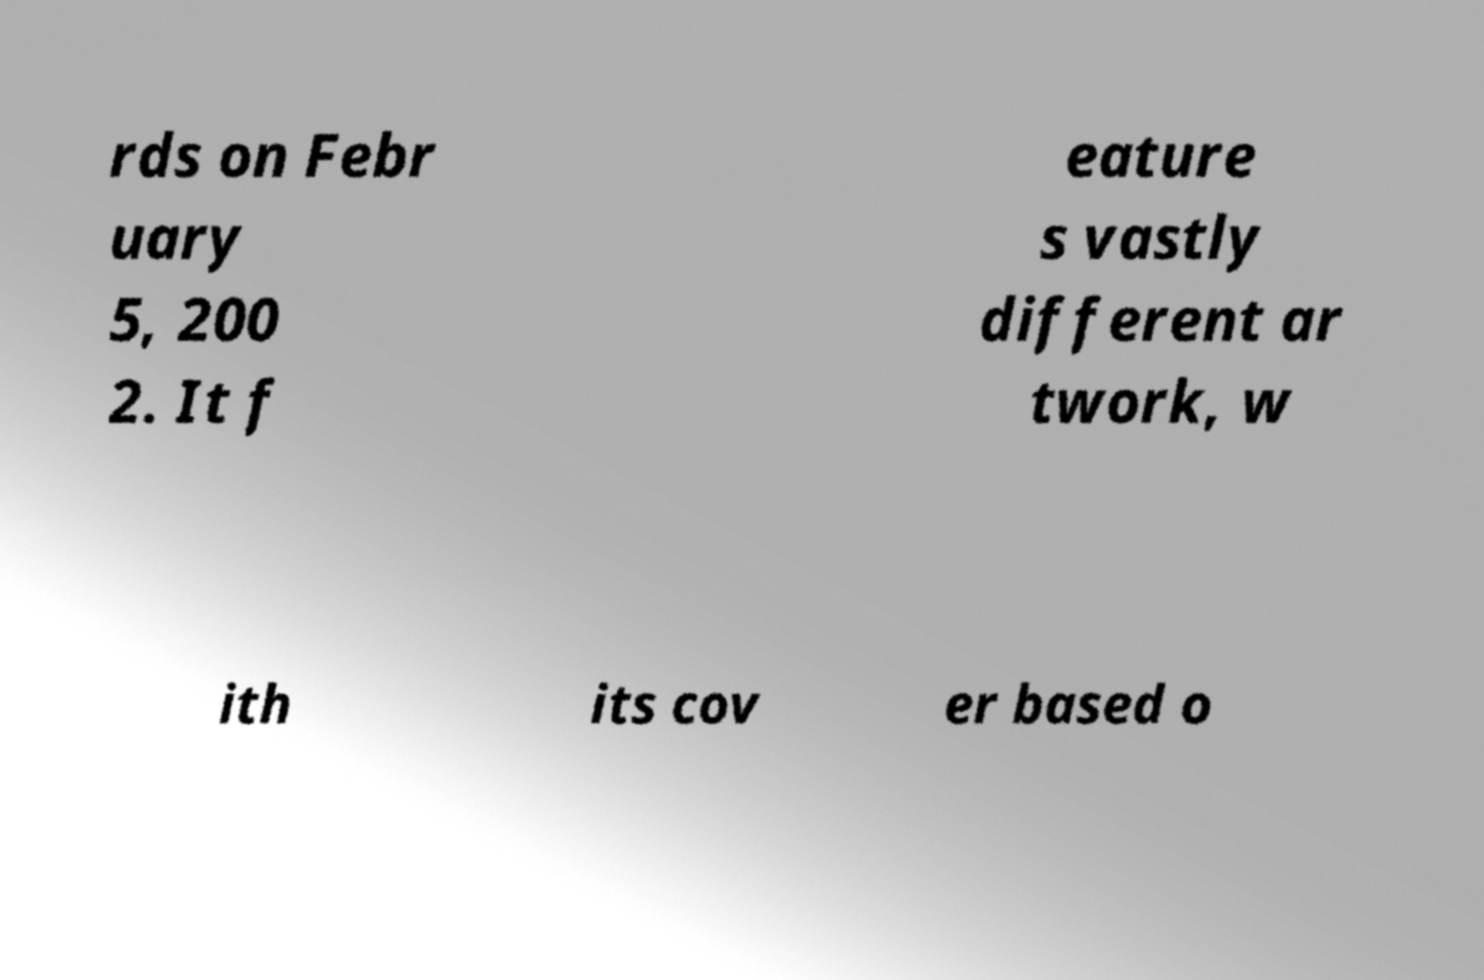What messages or text are displayed in this image? I need them in a readable, typed format. rds on Febr uary 5, 200 2. It f eature s vastly different ar twork, w ith its cov er based o 